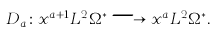Convert formula to latex. <formula><loc_0><loc_0><loc_500><loc_500>D _ { a } \colon x ^ { a + 1 } L ^ { 2 } \Omega ^ { * } \longrightarrow x ^ { a } L ^ { 2 } \Omega ^ { * } .</formula> 